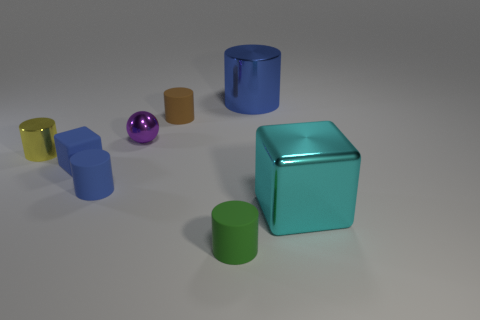Subtract all small brown cylinders. How many cylinders are left? 4 Subtract all cylinders. How many objects are left? 3 Subtract 3 cylinders. How many cylinders are left? 2 Subtract all blue cylinders. How many cylinders are left? 3 Add 2 big blue objects. How many objects exist? 10 Add 1 cyan shiny cubes. How many cyan shiny cubes exist? 2 Subtract 0 red blocks. How many objects are left? 8 Subtract all brown cylinders. Subtract all green balls. How many cylinders are left? 4 Subtract all blue blocks. How many blue balls are left? 0 Subtract all tiny metal things. Subtract all yellow cylinders. How many objects are left? 5 